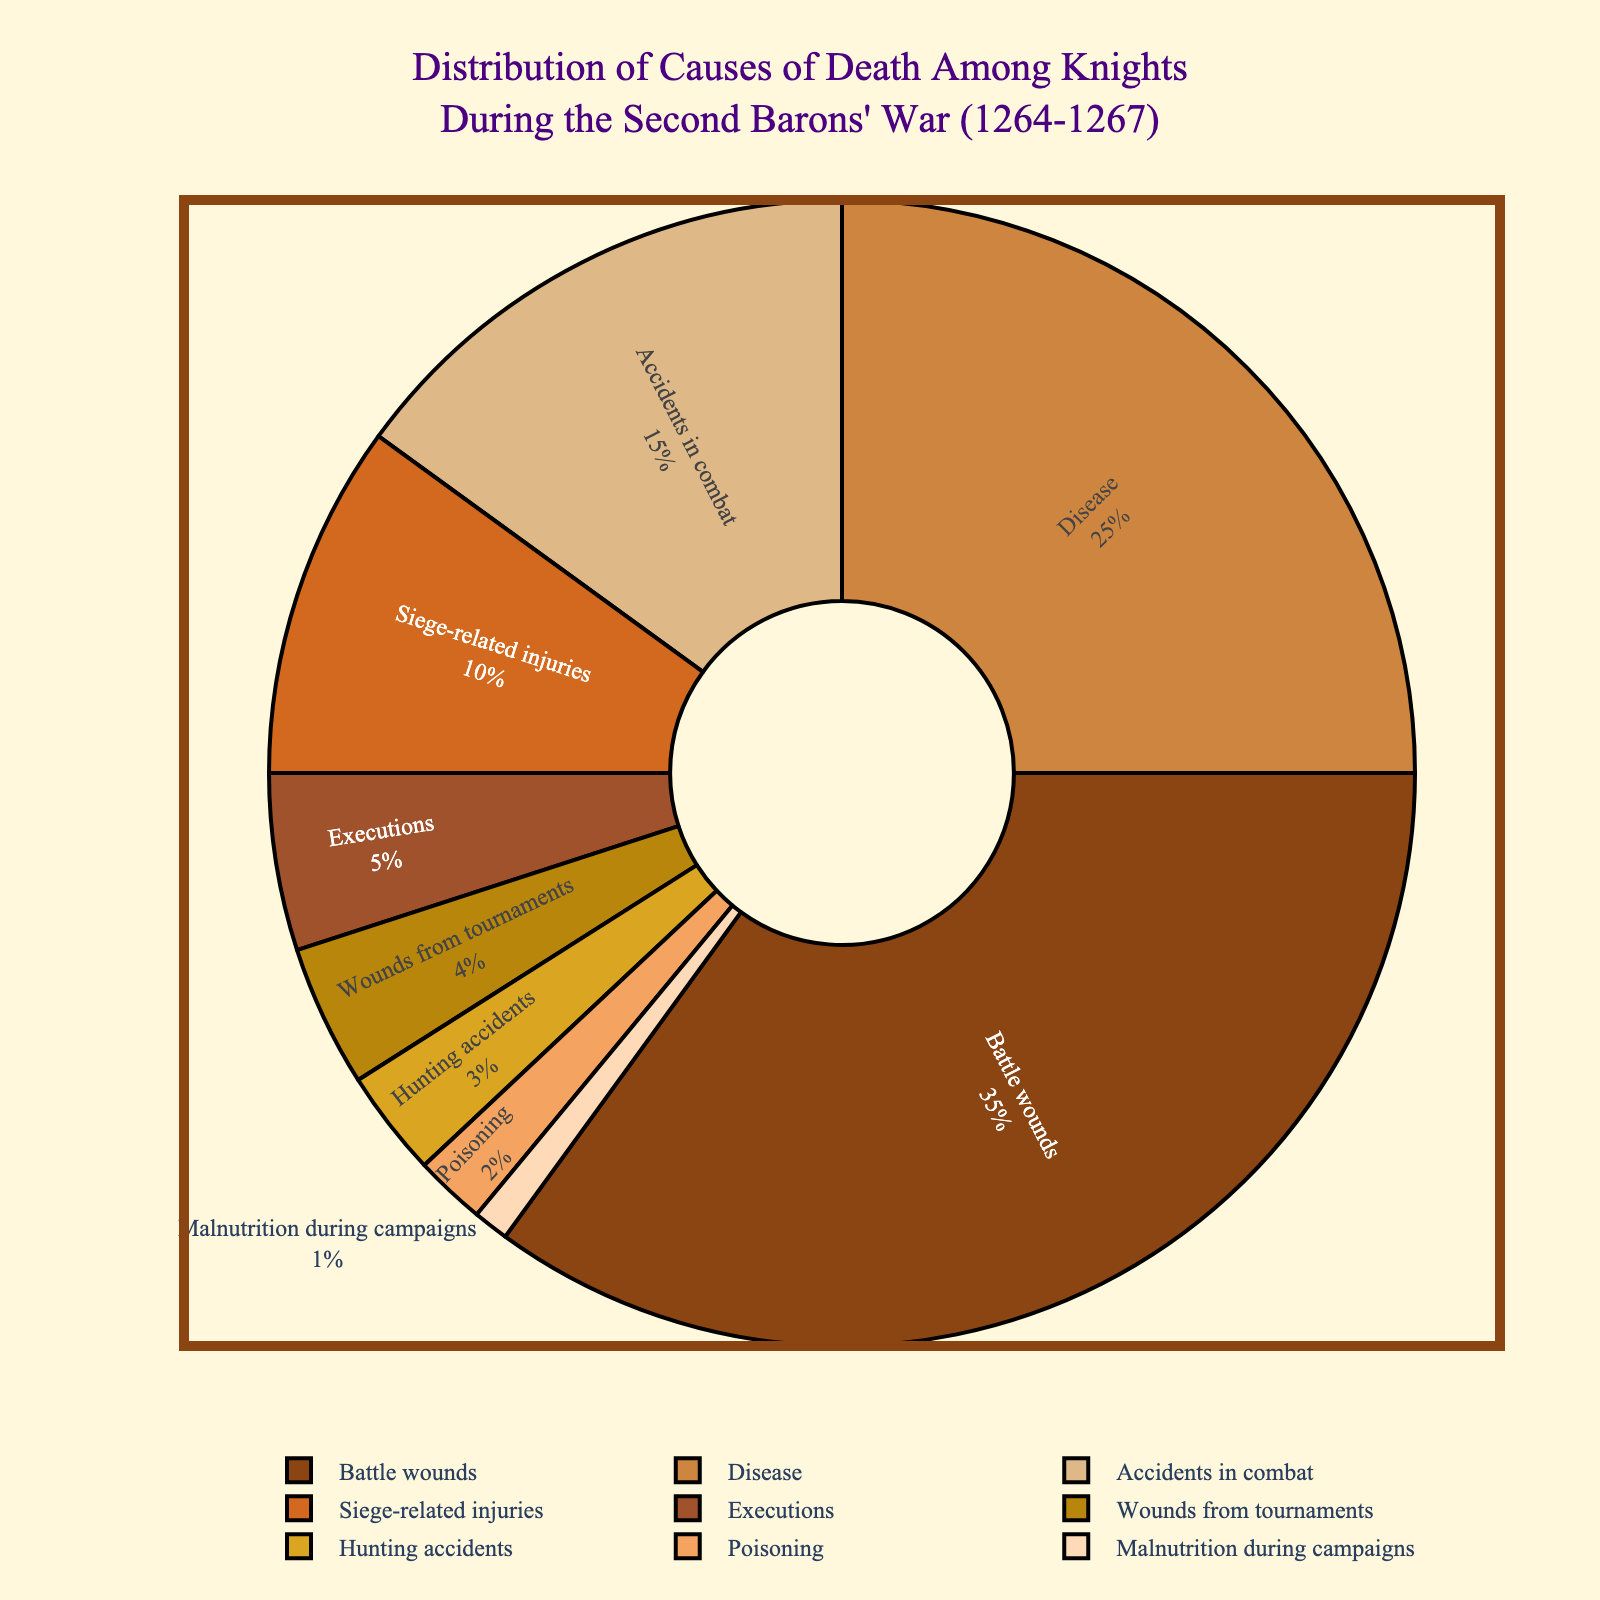Which cause of death has the largest percentage? Look at the "Battle wounds" section of the pie chart, which covers the largest area compared to the other sections, indicating it has the highest percentage.
Answer: Battle wounds What percentage of knights died due to disease? Find the segment labeled "Disease" on the pie chart and read the percentage value associated with it.
Answer: 25% How does the percentage of deaths due to accidents in combat compare to those due to siege-related injuries? Check the percentage values corresponding to "Accidents in combat" and "Siege-related injuries." Compare these two values by subtraction: 15% - 10% = 5%.
Answer: Accidents in combat are 5% higher than siege-related injuries What are the combined percentages of knights who died from executions and poisoning? Add the percentages for "Executions" and "Poisoning": 5% + 2% = 7%.
Answer: 7% Which causes of death have percentages under 5%? Identify the segments of the pie chart with percentage values under 5%: "Wounds from tournaments," "Hunting accidents," "Poisoning," and "Malnutrition during campaigns."
Answer: Wounds from tournaments, Hunting accidents, Poisoning, Malnutrition during campaigns Compare the percentage of knights who died from hunting accidents to those who died from malnutrition during campaigns. Which is higher, and by how much? Find the percentages for "Hunting accidents" (3%) and "Malnutrition during campaigns" (1%). Subtract the two: 3% - 1% = 2%.
Answer: Hunting accidents, 2% higher What's the sum of the percentages of deaths due to battle wounds, disease, and accidents in combat? Add the percentages for "Battle wounds," "Disease," and "Accidents in combat": 35% + 25% + 15% = 75%.
Answer: 75% Which segment of the pie chart is associated with the lowest percentage cause of death? Identify the segment with the smallest percentage value on the pie chart, which is "Malnutrition during campaigns" at 1%.
Answer: Malnutrition during campaigns How much more common were deaths due to disease compared to those due to executions? Subtract the percentage of "Executions" (5%) from "Disease" (25%): 25% - 5% = 20%.
Answer: 20% more common What are the visual characteristics (color and size) of the segment representing battle wounds? The segment for "Battle wounds" is the largest and has a specific color (let's assume dark brown based on the custom palette provided).
Answer: Largest, dark brown 